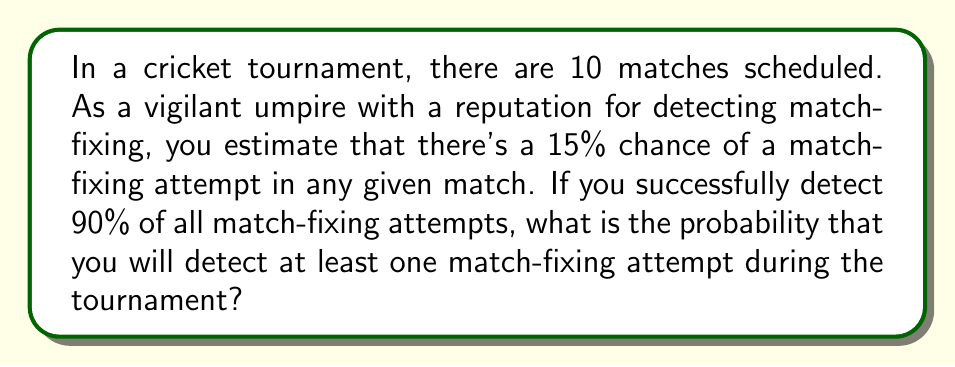Show me your answer to this math problem. Let's approach this step-by-step:

1) First, let's calculate the probability of a match-fixing attempt occurring and being detected in a single match:
   $P(\text{attempt and detect}) = P(\text{attempt}) \times P(\text{detect | attempt})$
   $= 0.15 \times 0.90 = 0.135$

2) The probability of not detecting a match-fixing attempt in a single match is the complement of this:
   $P(\text{not detect}) = 1 - 0.135 = 0.865$

3) For us to not detect any match-fixing attempts in the entire tournament, we would need to not detect it in all 10 matches. The probability of this is:
   $P(\text{detect none}) = (0.865)^{10}$

4) Therefore, the probability of detecting at least one match-fixing attempt is the complement of detecting none:
   $P(\text{detect at least one}) = 1 - P(\text{detect none})$
   $= 1 - (0.865)^{10}$

5) Let's calculate this:
   $1 - (0.865)^{10} = 1 - 0.2234 = 0.7766$

6) Converting to a percentage:
   $0.7766 \times 100\% = 77.66\%$
Answer: The probability of detecting at least one match-fixing attempt during the tournament is approximately 77.66%. 